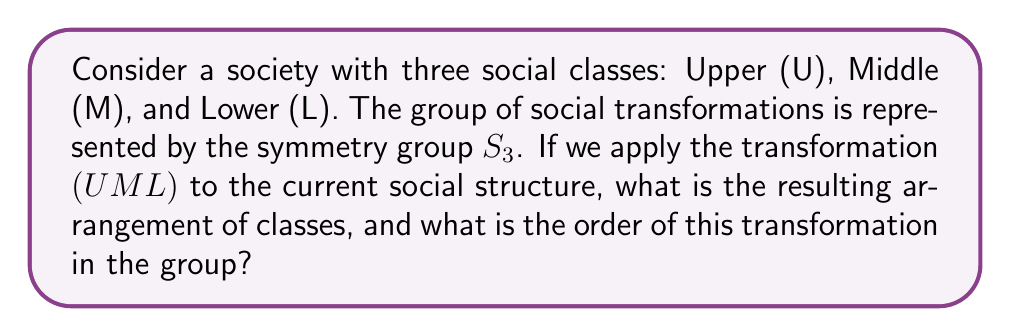Teach me how to tackle this problem. Let's approach this step-by-step:

1) First, we need to understand what $(UML)$ means in cycle notation:
   - It represents a cyclic permutation where U moves to M, M moves to L, and L moves to U.

2) To find the resulting arrangement:
   - U → M
   - M → L
   - L → U
   So, the new arrangement is (MLU).

3) To find the order of this transformation:
   - We need to determine how many times we must apply this transformation to get back to the original arrangement (UML).
   - Let's apply it repeatedly:
     (UML) → (MLU) → (LUM) → (UML)
   - We see that it takes 3 applications to return to the original state.

4) In group theory, the order of an element is the smallest positive integer $n$ such that $g^n = e$, where $e$ is the identity element.
   - In this case, $(UML)^3 = e$

5) Therefore, the order of the transformation $(UML)$ in $S_3$ is 3.

This analysis reflects how social structures can be represented and manipulated using group theory, providing a mathematical lens to view societal transformations.
Answer: (MLU); Order 3 